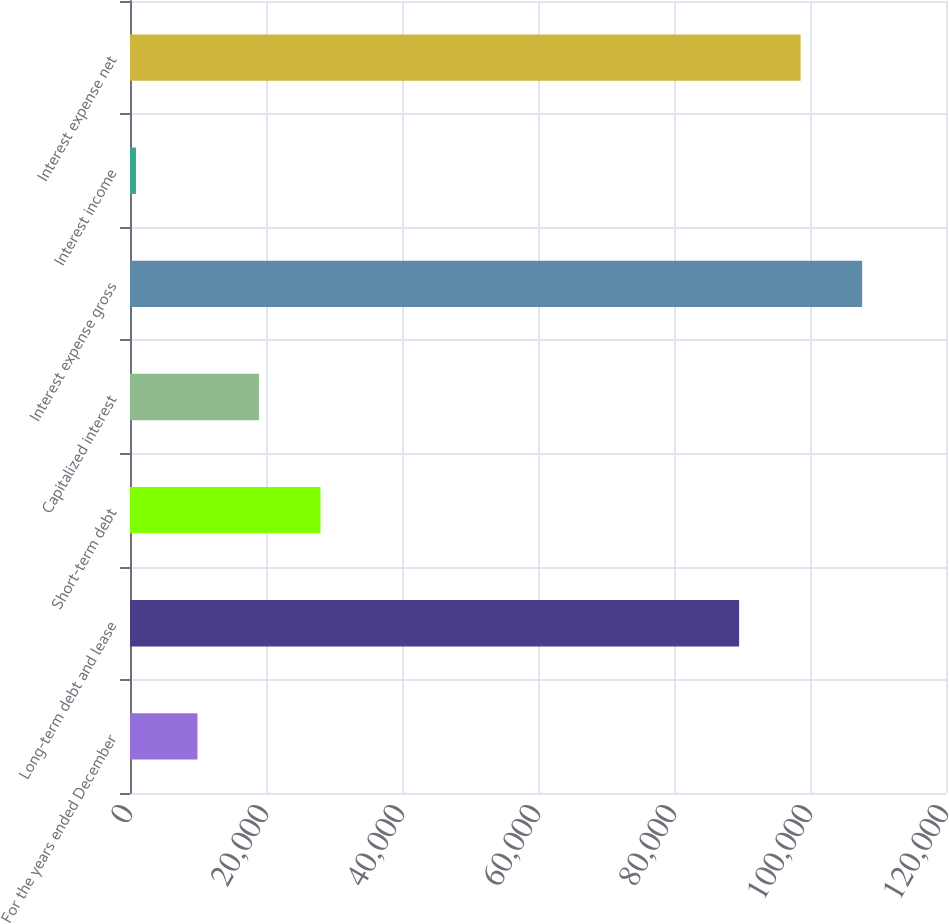Convert chart. <chart><loc_0><loc_0><loc_500><loc_500><bar_chart><fcel>For the years ended December<fcel>Long-term debt and lease<fcel>Short-term debt<fcel>Capitalized interest<fcel>Interest expense gross<fcel>Interest income<fcel>Interest expense net<nl><fcel>9922.9<fcel>89575<fcel>28014.7<fcel>18968.8<fcel>107667<fcel>877<fcel>98620.9<nl></chart> 